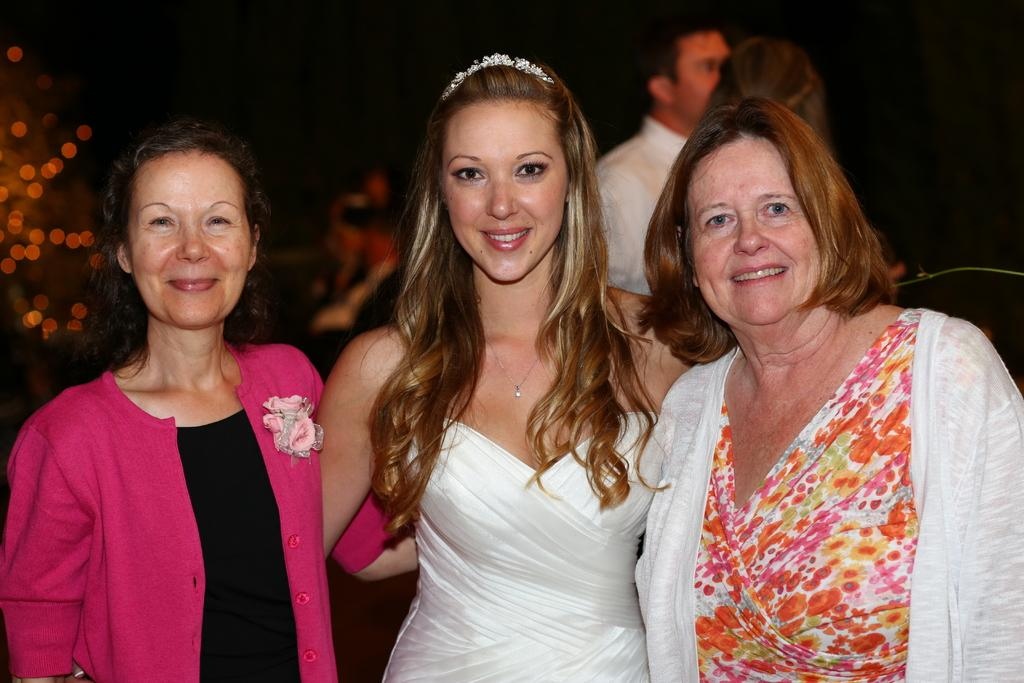What is happening with the women in the image? The women are standing and smiling in the image. Can you describe the man in the background of the image? There is a man in the background of the image, but no specific details are provided about him. What type of brake system is being used by the duck in the image? There is no duck present in the image, so there is no brake system to discuss. 